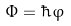<formula> <loc_0><loc_0><loc_500><loc_500>\Phi = \hbar { \varphi }</formula> 